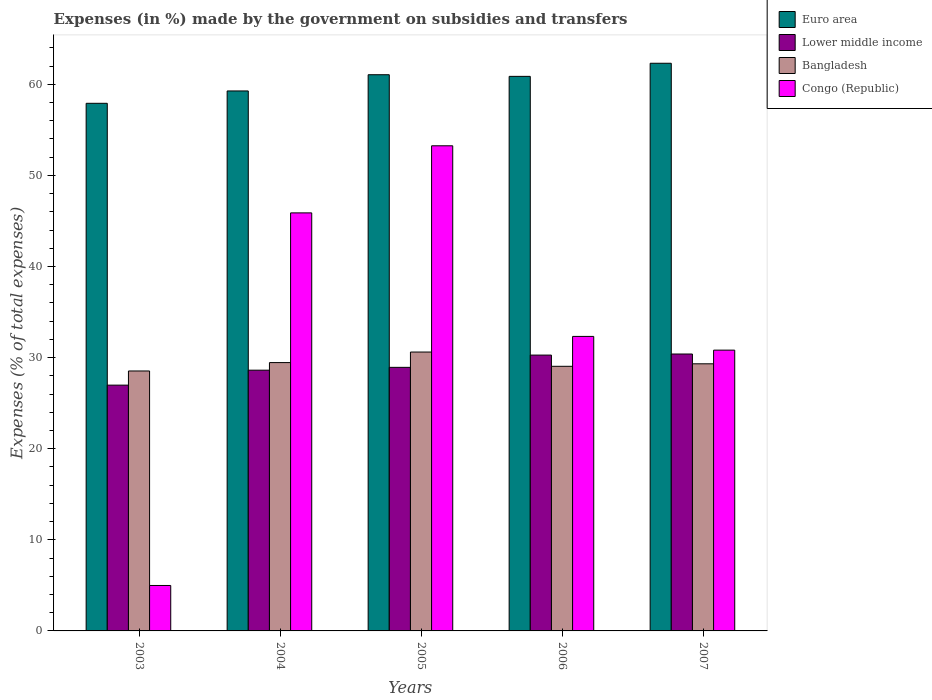How many different coloured bars are there?
Provide a succinct answer. 4. Are the number of bars per tick equal to the number of legend labels?
Keep it short and to the point. Yes. What is the label of the 1st group of bars from the left?
Offer a very short reply. 2003. In how many cases, is the number of bars for a given year not equal to the number of legend labels?
Provide a short and direct response. 0. What is the percentage of expenses made by the government on subsidies and transfers in Bangladesh in 2003?
Ensure brevity in your answer.  28.53. Across all years, what is the maximum percentage of expenses made by the government on subsidies and transfers in Euro area?
Ensure brevity in your answer.  62.31. Across all years, what is the minimum percentage of expenses made by the government on subsidies and transfers in Bangladesh?
Your answer should be very brief. 28.53. In which year was the percentage of expenses made by the government on subsidies and transfers in Euro area minimum?
Provide a succinct answer. 2003. What is the total percentage of expenses made by the government on subsidies and transfers in Lower middle income in the graph?
Offer a very short reply. 145.2. What is the difference between the percentage of expenses made by the government on subsidies and transfers in Bangladesh in 2003 and that in 2006?
Your response must be concise. -0.51. What is the difference between the percentage of expenses made by the government on subsidies and transfers in Bangladesh in 2007 and the percentage of expenses made by the government on subsidies and transfers in Euro area in 2006?
Ensure brevity in your answer.  -31.55. What is the average percentage of expenses made by the government on subsidies and transfers in Congo (Republic) per year?
Your answer should be very brief. 33.45. In the year 2007, what is the difference between the percentage of expenses made by the government on subsidies and transfers in Lower middle income and percentage of expenses made by the government on subsidies and transfers in Bangladesh?
Provide a succinct answer. 1.07. In how many years, is the percentage of expenses made by the government on subsidies and transfers in Lower middle income greater than 26 %?
Make the answer very short. 5. What is the ratio of the percentage of expenses made by the government on subsidies and transfers in Lower middle income in 2004 to that in 2007?
Make the answer very short. 0.94. What is the difference between the highest and the second highest percentage of expenses made by the government on subsidies and transfers in Congo (Republic)?
Give a very brief answer. 7.37. What is the difference between the highest and the lowest percentage of expenses made by the government on subsidies and transfers in Lower middle income?
Make the answer very short. 3.42. In how many years, is the percentage of expenses made by the government on subsidies and transfers in Congo (Republic) greater than the average percentage of expenses made by the government on subsidies and transfers in Congo (Republic) taken over all years?
Your answer should be very brief. 2. Is it the case that in every year, the sum of the percentage of expenses made by the government on subsidies and transfers in Bangladesh and percentage of expenses made by the government on subsidies and transfers in Lower middle income is greater than the sum of percentage of expenses made by the government on subsidies and transfers in Euro area and percentage of expenses made by the government on subsidies and transfers in Congo (Republic)?
Offer a very short reply. No. What does the 1st bar from the right in 2003 represents?
Offer a terse response. Congo (Republic). Is it the case that in every year, the sum of the percentage of expenses made by the government on subsidies and transfers in Bangladesh and percentage of expenses made by the government on subsidies and transfers in Lower middle income is greater than the percentage of expenses made by the government on subsidies and transfers in Congo (Republic)?
Ensure brevity in your answer.  Yes. How many bars are there?
Your answer should be very brief. 20. What is the difference between two consecutive major ticks on the Y-axis?
Your response must be concise. 10. Does the graph contain grids?
Keep it short and to the point. No. Where does the legend appear in the graph?
Make the answer very short. Top right. How many legend labels are there?
Provide a succinct answer. 4. What is the title of the graph?
Offer a terse response. Expenses (in %) made by the government on subsidies and transfers. What is the label or title of the Y-axis?
Provide a short and direct response. Expenses (% of total expenses). What is the Expenses (% of total expenses) in Euro area in 2003?
Provide a short and direct response. 57.91. What is the Expenses (% of total expenses) in Lower middle income in 2003?
Keep it short and to the point. 26.98. What is the Expenses (% of total expenses) of Bangladesh in 2003?
Offer a very short reply. 28.53. What is the Expenses (% of total expenses) in Congo (Republic) in 2003?
Keep it short and to the point. 4.99. What is the Expenses (% of total expenses) of Euro area in 2004?
Keep it short and to the point. 59.27. What is the Expenses (% of total expenses) of Lower middle income in 2004?
Your answer should be very brief. 28.62. What is the Expenses (% of total expenses) of Bangladesh in 2004?
Provide a succinct answer. 29.45. What is the Expenses (% of total expenses) in Congo (Republic) in 2004?
Make the answer very short. 45.89. What is the Expenses (% of total expenses) of Euro area in 2005?
Provide a short and direct response. 61.05. What is the Expenses (% of total expenses) in Lower middle income in 2005?
Provide a succinct answer. 28.93. What is the Expenses (% of total expenses) in Bangladesh in 2005?
Make the answer very short. 30.61. What is the Expenses (% of total expenses) of Congo (Republic) in 2005?
Ensure brevity in your answer.  53.25. What is the Expenses (% of total expenses) in Euro area in 2006?
Offer a very short reply. 60.87. What is the Expenses (% of total expenses) of Lower middle income in 2006?
Your answer should be compact. 30.28. What is the Expenses (% of total expenses) of Bangladesh in 2006?
Make the answer very short. 29.05. What is the Expenses (% of total expenses) in Congo (Republic) in 2006?
Your answer should be very brief. 32.33. What is the Expenses (% of total expenses) in Euro area in 2007?
Offer a terse response. 62.31. What is the Expenses (% of total expenses) of Lower middle income in 2007?
Offer a terse response. 30.39. What is the Expenses (% of total expenses) in Bangladesh in 2007?
Your answer should be compact. 29.32. What is the Expenses (% of total expenses) of Congo (Republic) in 2007?
Make the answer very short. 30.82. Across all years, what is the maximum Expenses (% of total expenses) of Euro area?
Make the answer very short. 62.31. Across all years, what is the maximum Expenses (% of total expenses) of Lower middle income?
Ensure brevity in your answer.  30.39. Across all years, what is the maximum Expenses (% of total expenses) in Bangladesh?
Keep it short and to the point. 30.61. Across all years, what is the maximum Expenses (% of total expenses) of Congo (Republic)?
Provide a succinct answer. 53.25. Across all years, what is the minimum Expenses (% of total expenses) in Euro area?
Your answer should be compact. 57.91. Across all years, what is the minimum Expenses (% of total expenses) in Lower middle income?
Ensure brevity in your answer.  26.98. Across all years, what is the minimum Expenses (% of total expenses) of Bangladesh?
Offer a terse response. 28.53. Across all years, what is the minimum Expenses (% of total expenses) in Congo (Republic)?
Provide a short and direct response. 4.99. What is the total Expenses (% of total expenses) in Euro area in the graph?
Ensure brevity in your answer.  301.41. What is the total Expenses (% of total expenses) in Lower middle income in the graph?
Your response must be concise. 145.2. What is the total Expenses (% of total expenses) in Bangladesh in the graph?
Ensure brevity in your answer.  146.96. What is the total Expenses (% of total expenses) in Congo (Republic) in the graph?
Your answer should be very brief. 167.27. What is the difference between the Expenses (% of total expenses) of Euro area in 2003 and that in 2004?
Offer a terse response. -1.36. What is the difference between the Expenses (% of total expenses) of Lower middle income in 2003 and that in 2004?
Your answer should be very brief. -1.64. What is the difference between the Expenses (% of total expenses) in Bangladesh in 2003 and that in 2004?
Your answer should be compact. -0.92. What is the difference between the Expenses (% of total expenses) in Congo (Republic) in 2003 and that in 2004?
Ensure brevity in your answer.  -40.9. What is the difference between the Expenses (% of total expenses) in Euro area in 2003 and that in 2005?
Your response must be concise. -3.14. What is the difference between the Expenses (% of total expenses) in Lower middle income in 2003 and that in 2005?
Make the answer very short. -1.95. What is the difference between the Expenses (% of total expenses) in Bangladesh in 2003 and that in 2005?
Offer a very short reply. -2.08. What is the difference between the Expenses (% of total expenses) of Congo (Republic) in 2003 and that in 2005?
Your response must be concise. -48.26. What is the difference between the Expenses (% of total expenses) of Euro area in 2003 and that in 2006?
Make the answer very short. -2.96. What is the difference between the Expenses (% of total expenses) in Lower middle income in 2003 and that in 2006?
Ensure brevity in your answer.  -3.3. What is the difference between the Expenses (% of total expenses) of Bangladesh in 2003 and that in 2006?
Offer a very short reply. -0.51. What is the difference between the Expenses (% of total expenses) in Congo (Republic) in 2003 and that in 2006?
Provide a succinct answer. -27.34. What is the difference between the Expenses (% of total expenses) in Euro area in 2003 and that in 2007?
Offer a very short reply. -4.4. What is the difference between the Expenses (% of total expenses) in Lower middle income in 2003 and that in 2007?
Ensure brevity in your answer.  -3.42. What is the difference between the Expenses (% of total expenses) in Bangladesh in 2003 and that in 2007?
Your answer should be compact. -0.79. What is the difference between the Expenses (% of total expenses) of Congo (Republic) in 2003 and that in 2007?
Your response must be concise. -25.83. What is the difference between the Expenses (% of total expenses) in Euro area in 2004 and that in 2005?
Ensure brevity in your answer.  -1.78. What is the difference between the Expenses (% of total expenses) in Lower middle income in 2004 and that in 2005?
Offer a terse response. -0.31. What is the difference between the Expenses (% of total expenses) of Bangladesh in 2004 and that in 2005?
Provide a succinct answer. -1.16. What is the difference between the Expenses (% of total expenses) in Congo (Republic) in 2004 and that in 2005?
Ensure brevity in your answer.  -7.37. What is the difference between the Expenses (% of total expenses) in Euro area in 2004 and that in 2006?
Provide a short and direct response. -1.6. What is the difference between the Expenses (% of total expenses) of Lower middle income in 2004 and that in 2006?
Give a very brief answer. -1.66. What is the difference between the Expenses (% of total expenses) in Bangladesh in 2004 and that in 2006?
Your answer should be compact. 0.41. What is the difference between the Expenses (% of total expenses) in Congo (Republic) in 2004 and that in 2006?
Your response must be concise. 13.56. What is the difference between the Expenses (% of total expenses) of Euro area in 2004 and that in 2007?
Offer a very short reply. -3.04. What is the difference between the Expenses (% of total expenses) in Lower middle income in 2004 and that in 2007?
Provide a short and direct response. -1.78. What is the difference between the Expenses (% of total expenses) of Bangladesh in 2004 and that in 2007?
Ensure brevity in your answer.  0.13. What is the difference between the Expenses (% of total expenses) of Congo (Republic) in 2004 and that in 2007?
Make the answer very short. 15.06. What is the difference between the Expenses (% of total expenses) in Euro area in 2005 and that in 2006?
Ensure brevity in your answer.  0.18. What is the difference between the Expenses (% of total expenses) in Lower middle income in 2005 and that in 2006?
Provide a short and direct response. -1.35. What is the difference between the Expenses (% of total expenses) in Bangladesh in 2005 and that in 2006?
Your answer should be very brief. 1.57. What is the difference between the Expenses (% of total expenses) of Congo (Republic) in 2005 and that in 2006?
Offer a very short reply. 20.92. What is the difference between the Expenses (% of total expenses) in Euro area in 2005 and that in 2007?
Make the answer very short. -1.26. What is the difference between the Expenses (% of total expenses) in Lower middle income in 2005 and that in 2007?
Keep it short and to the point. -1.46. What is the difference between the Expenses (% of total expenses) of Bangladesh in 2005 and that in 2007?
Provide a short and direct response. 1.29. What is the difference between the Expenses (% of total expenses) in Congo (Republic) in 2005 and that in 2007?
Ensure brevity in your answer.  22.43. What is the difference between the Expenses (% of total expenses) in Euro area in 2006 and that in 2007?
Offer a very short reply. -1.44. What is the difference between the Expenses (% of total expenses) of Lower middle income in 2006 and that in 2007?
Your answer should be compact. -0.12. What is the difference between the Expenses (% of total expenses) of Bangladesh in 2006 and that in 2007?
Your response must be concise. -0.27. What is the difference between the Expenses (% of total expenses) of Congo (Republic) in 2006 and that in 2007?
Give a very brief answer. 1.5. What is the difference between the Expenses (% of total expenses) of Euro area in 2003 and the Expenses (% of total expenses) of Lower middle income in 2004?
Your response must be concise. 29.29. What is the difference between the Expenses (% of total expenses) in Euro area in 2003 and the Expenses (% of total expenses) in Bangladesh in 2004?
Offer a very short reply. 28.46. What is the difference between the Expenses (% of total expenses) of Euro area in 2003 and the Expenses (% of total expenses) of Congo (Republic) in 2004?
Provide a short and direct response. 12.03. What is the difference between the Expenses (% of total expenses) in Lower middle income in 2003 and the Expenses (% of total expenses) in Bangladesh in 2004?
Give a very brief answer. -2.47. What is the difference between the Expenses (% of total expenses) in Lower middle income in 2003 and the Expenses (% of total expenses) in Congo (Republic) in 2004?
Provide a short and direct response. -18.91. What is the difference between the Expenses (% of total expenses) of Bangladesh in 2003 and the Expenses (% of total expenses) of Congo (Republic) in 2004?
Ensure brevity in your answer.  -17.35. What is the difference between the Expenses (% of total expenses) in Euro area in 2003 and the Expenses (% of total expenses) in Lower middle income in 2005?
Provide a succinct answer. 28.98. What is the difference between the Expenses (% of total expenses) of Euro area in 2003 and the Expenses (% of total expenses) of Bangladesh in 2005?
Your response must be concise. 27.3. What is the difference between the Expenses (% of total expenses) of Euro area in 2003 and the Expenses (% of total expenses) of Congo (Republic) in 2005?
Provide a short and direct response. 4.66. What is the difference between the Expenses (% of total expenses) in Lower middle income in 2003 and the Expenses (% of total expenses) in Bangladesh in 2005?
Offer a terse response. -3.63. What is the difference between the Expenses (% of total expenses) of Lower middle income in 2003 and the Expenses (% of total expenses) of Congo (Republic) in 2005?
Give a very brief answer. -26.27. What is the difference between the Expenses (% of total expenses) of Bangladesh in 2003 and the Expenses (% of total expenses) of Congo (Republic) in 2005?
Offer a very short reply. -24.72. What is the difference between the Expenses (% of total expenses) in Euro area in 2003 and the Expenses (% of total expenses) in Lower middle income in 2006?
Provide a short and direct response. 27.64. What is the difference between the Expenses (% of total expenses) in Euro area in 2003 and the Expenses (% of total expenses) in Bangladesh in 2006?
Offer a very short reply. 28.87. What is the difference between the Expenses (% of total expenses) of Euro area in 2003 and the Expenses (% of total expenses) of Congo (Republic) in 2006?
Offer a very short reply. 25.59. What is the difference between the Expenses (% of total expenses) of Lower middle income in 2003 and the Expenses (% of total expenses) of Bangladesh in 2006?
Keep it short and to the point. -2.07. What is the difference between the Expenses (% of total expenses) in Lower middle income in 2003 and the Expenses (% of total expenses) in Congo (Republic) in 2006?
Offer a terse response. -5.35. What is the difference between the Expenses (% of total expenses) of Bangladesh in 2003 and the Expenses (% of total expenses) of Congo (Republic) in 2006?
Provide a succinct answer. -3.79. What is the difference between the Expenses (% of total expenses) of Euro area in 2003 and the Expenses (% of total expenses) of Lower middle income in 2007?
Give a very brief answer. 27.52. What is the difference between the Expenses (% of total expenses) in Euro area in 2003 and the Expenses (% of total expenses) in Bangladesh in 2007?
Offer a very short reply. 28.59. What is the difference between the Expenses (% of total expenses) in Euro area in 2003 and the Expenses (% of total expenses) in Congo (Republic) in 2007?
Provide a succinct answer. 27.09. What is the difference between the Expenses (% of total expenses) in Lower middle income in 2003 and the Expenses (% of total expenses) in Bangladesh in 2007?
Your response must be concise. -2.34. What is the difference between the Expenses (% of total expenses) in Lower middle income in 2003 and the Expenses (% of total expenses) in Congo (Republic) in 2007?
Give a very brief answer. -3.84. What is the difference between the Expenses (% of total expenses) of Bangladesh in 2003 and the Expenses (% of total expenses) of Congo (Republic) in 2007?
Keep it short and to the point. -2.29. What is the difference between the Expenses (% of total expenses) in Euro area in 2004 and the Expenses (% of total expenses) in Lower middle income in 2005?
Provide a short and direct response. 30.34. What is the difference between the Expenses (% of total expenses) of Euro area in 2004 and the Expenses (% of total expenses) of Bangladesh in 2005?
Make the answer very short. 28.66. What is the difference between the Expenses (% of total expenses) in Euro area in 2004 and the Expenses (% of total expenses) in Congo (Republic) in 2005?
Offer a very short reply. 6.02. What is the difference between the Expenses (% of total expenses) in Lower middle income in 2004 and the Expenses (% of total expenses) in Bangladesh in 2005?
Give a very brief answer. -1.99. What is the difference between the Expenses (% of total expenses) in Lower middle income in 2004 and the Expenses (% of total expenses) in Congo (Republic) in 2005?
Offer a very short reply. -24.63. What is the difference between the Expenses (% of total expenses) in Bangladesh in 2004 and the Expenses (% of total expenses) in Congo (Republic) in 2005?
Provide a succinct answer. -23.8. What is the difference between the Expenses (% of total expenses) of Euro area in 2004 and the Expenses (% of total expenses) of Lower middle income in 2006?
Ensure brevity in your answer.  28.99. What is the difference between the Expenses (% of total expenses) of Euro area in 2004 and the Expenses (% of total expenses) of Bangladesh in 2006?
Ensure brevity in your answer.  30.22. What is the difference between the Expenses (% of total expenses) of Euro area in 2004 and the Expenses (% of total expenses) of Congo (Republic) in 2006?
Your answer should be compact. 26.94. What is the difference between the Expenses (% of total expenses) of Lower middle income in 2004 and the Expenses (% of total expenses) of Bangladesh in 2006?
Make the answer very short. -0.43. What is the difference between the Expenses (% of total expenses) in Lower middle income in 2004 and the Expenses (% of total expenses) in Congo (Republic) in 2006?
Offer a very short reply. -3.71. What is the difference between the Expenses (% of total expenses) of Bangladesh in 2004 and the Expenses (% of total expenses) of Congo (Republic) in 2006?
Provide a succinct answer. -2.87. What is the difference between the Expenses (% of total expenses) of Euro area in 2004 and the Expenses (% of total expenses) of Lower middle income in 2007?
Provide a short and direct response. 28.87. What is the difference between the Expenses (% of total expenses) in Euro area in 2004 and the Expenses (% of total expenses) in Bangladesh in 2007?
Ensure brevity in your answer.  29.95. What is the difference between the Expenses (% of total expenses) in Euro area in 2004 and the Expenses (% of total expenses) in Congo (Republic) in 2007?
Provide a succinct answer. 28.45. What is the difference between the Expenses (% of total expenses) of Lower middle income in 2004 and the Expenses (% of total expenses) of Bangladesh in 2007?
Give a very brief answer. -0.7. What is the difference between the Expenses (% of total expenses) in Lower middle income in 2004 and the Expenses (% of total expenses) in Congo (Republic) in 2007?
Provide a short and direct response. -2.2. What is the difference between the Expenses (% of total expenses) in Bangladesh in 2004 and the Expenses (% of total expenses) in Congo (Republic) in 2007?
Provide a succinct answer. -1.37. What is the difference between the Expenses (% of total expenses) of Euro area in 2005 and the Expenses (% of total expenses) of Lower middle income in 2006?
Offer a very short reply. 30.77. What is the difference between the Expenses (% of total expenses) in Euro area in 2005 and the Expenses (% of total expenses) in Bangladesh in 2006?
Offer a terse response. 32. What is the difference between the Expenses (% of total expenses) in Euro area in 2005 and the Expenses (% of total expenses) in Congo (Republic) in 2006?
Keep it short and to the point. 28.72. What is the difference between the Expenses (% of total expenses) of Lower middle income in 2005 and the Expenses (% of total expenses) of Bangladesh in 2006?
Keep it short and to the point. -0.12. What is the difference between the Expenses (% of total expenses) in Lower middle income in 2005 and the Expenses (% of total expenses) in Congo (Republic) in 2006?
Ensure brevity in your answer.  -3.4. What is the difference between the Expenses (% of total expenses) of Bangladesh in 2005 and the Expenses (% of total expenses) of Congo (Republic) in 2006?
Offer a very short reply. -1.71. What is the difference between the Expenses (% of total expenses) of Euro area in 2005 and the Expenses (% of total expenses) of Lower middle income in 2007?
Provide a short and direct response. 30.66. What is the difference between the Expenses (% of total expenses) in Euro area in 2005 and the Expenses (% of total expenses) in Bangladesh in 2007?
Your response must be concise. 31.73. What is the difference between the Expenses (% of total expenses) in Euro area in 2005 and the Expenses (% of total expenses) in Congo (Republic) in 2007?
Offer a terse response. 30.23. What is the difference between the Expenses (% of total expenses) of Lower middle income in 2005 and the Expenses (% of total expenses) of Bangladesh in 2007?
Make the answer very short. -0.39. What is the difference between the Expenses (% of total expenses) in Lower middle income in 2005 and the Expenses (% of total expenses) in Congo (Republic) in 2007?
Provide a short and direct response. -1.89. What is the difference between the Expenses (% of total expenses) in Bangladesh in 2005 and the Expenses (% of total expenses) in Congo (Republic) in 2007?
Your response must be concise. -0.21. What is the difference between the Expenses (% of total expenses) of Euro area in 2006 and the Expenses (% of total expenses) of Lower middle income in 2007?
Your response must be concise. 30.48. What is the difference between the Expenses (% of total expenses) of Euro area in 2006 and the Expenses (% of total expenses) of Bangladesh in 2007?
Offer a terse response. 31.55. What is the difference between the Expenses (% of total expenses) of Euro area in 2006 and the Expenses (% of total expenses) of Congo (Republic) in 2007?
Ensure brevity in your answer.  30.05. What is the difference between the Expenses (% of total expenses) of Lower middle income in 2006 and the Expenses (% of total expenses) of Bangladesh in 2007?
Offer a very short reply. 0.96. What is the difference between the Expenses (% of total expenses) in Lower middle income in 2006 and the Expenses (% of total expenses) in Congo (Republic) in 2007?
Give a very brief answer. -0.54. What is the difference between the Expenses (% of total expenses) of Bangladesh in 2006 and the Expenses (% of total expenses) of Congo (Republic) in 2007?
Provide a succinct answer. -1.78. What is the average Expenses (% of total expenses) of Euro area per year?
Give a very brief answer. 60.28. What is the average Expenses (% of total expenses) in Lower middle income per year?
Offer a terse response. 29.04. What is the average Expenses (% of total expenses) in Bangladesh per year?
Keep it short and to the point. 29.39. What is the average Expenses (% of total expenses) of Congo (Republic) per year?
Provide a succinct answer. 33.45. In the year 2003, what is the difference between the Expenses (% of total expenses) of Euro area and Expenses (% of total expenses) of Lower middle income?
Ensure brevity in your answer.  30.93. In the year 2003, what is the difference between the Expenses (% of total expenses) of Euro area and Expenses (% of total expenses) of Bangladesh?
Give a very brief answer. 29.38. In the year 2003, what is the difference between the Expenses (% of total expenses) in Euro area and Expenses (% of total expenses) in Congo (Republic)?
Your answer should be very brief. 52.92. In the year 2003, what is the difference between the Expenses (% of total expenses) in Lower middle income and Expenses (% of total expenses) in Bangladesh?
Your response must be concise. -1.55. In the year 2003, what is the difference between the Expenses (% of total expenses) of Lower middle income and Expenses (% of total expenses) of Congo (Republic)?
Provide a short and direct response. 21.99. In the year 2003, what is the difference between the Expenses (% of total expenses) of Bangladesh and Expenses (% of total expenses) of Congo (Republic)?
Your answer should be compact. 23.54. In the year 2004, what is the difference between the Expenses (% of total expenses) of Euro area and Expenses (% of total expenses) of Lower middle income?
Provide a succinct answer. 30.65. In the year 2004, what is the difference between the Expenses (% of total expenses) of Euro area and Expenses (% of total expenses) of Bangladesh?
Provide a short and direct response. 29.82. In the year 2004, what is the difference between the Expenses (% of total expenses) of Euro area and Expenses (% of total expenses) of Congo (Republic)?
Your response must be concise. 13.38. In the year 2004, what is the difference between the Expenses (% of total expenses) of Lower middle income and Expenses (% of total expenses) of Bangladesh?
Offer a terse response. -0.83. In the year 2004, what is the difference between the Expenses (% of total expenses) of Lower middle income and Expenses (% of total expenses) of Congo (Republic)?
Offer a terse response. -17.27. In the year 2004, what is the difference between the Expenses (% of total expenses) in Bangladesh and Expenses (% of total expenses) in Congo (Republic)?
Provide a succinct answer. -16.43. In the year 2005, what is the difference between the Expenses (% of total expenses) of Euro area and Expenses (% of total expenses) of Lower middle income?
Keep it short and to the point. 32.12. In the year 2005, what is the difference between the Expenses (% of total expenses) in Euro area and Expenses (% of total expenses) in Bangladesh?
Offer a very short reply. 30.44. In the year 2005, what is the difference between the Expenses (% of total expenses) in Euro area and Expenses (% of total expenses) in Congo (Republic)?
Make the answer very short. 7.8. In the year 2005, what is the difference between the Expenses (% of total expenses) of Lower middle income and Expenses (% of total expenses) of Bangladesh?
Ensure brevity in your answer.  -1.68. In the year 2005, what is the difference between the Expenses (% of total expenses) of Lower middle income and Expenses (% of total expenses) of Congo (Republic)?
Offer a very short reply. -24.32. In the year 2005, what is the difference between the Expenses (% of total expenses) of Bangladesh and Expenses (% of total expenses) of Congo (Republic)?
Offer a terse response. -22.64. In the year 2006, what is the difference between the Expenses (% of total expenses) of Euro area and Expenses (% of total expenses) of Lower middle income?
Your answer should be compact. 30.59. In the year 2006, what is the difference between the Expenses (% of total expenses) in Euro area and Expenses (% of total expenses) in Bangladesh?
Ensure brevity in your answer.  31.82. In the year 2006, what is the difference between the Expenses (% of total expenses) of Euro area and Expenses (% of total expenses) of Congo (Republic)?
Your answer should be very brief. 28.54. In the year 2006, what is the difference between the Expenses (% of total expenses) of Lower middle income and Expenses (% of total expenses) of Bangladesh?
Provide a short and direct response. 1.23. In the year 2006, what is the difference between the Expenses (% of total expenses) of Lower middle income and Expenses (% of total expenses) of Congo (Republic)?
Provide a succinct answer. -2.05. In the year 2006, what is the difference between the Expenses (% of total expenses) in Bangladesh and Expenses (% of total expenses) in Congo (Republic)?
Your answer should be compact. -3.28. In the year 2007, what is the difference between the Expenses (% of total expenses) in Euro area and Expenses (% of total expenses) in Lower middle income?
Offer a terse response. 31.91. In the year 2007, what is the difference between the Expenses (% of total expenses) of Euro area and Expenses (% of total expenses) of Bangladesh?
Your answer should be compact. 32.99. In the year 2007, what is the difference between the Expenses (% of total expenses) of Euro area and Expenses (% of total expenses) of Congo (Republic)?
Offer a terse response. 31.49. In the year 2007, what is the difference between the Expenses (% of total expenses) in Lower middle income and Expenses (% of total expenses) in Bangladesh?
Your answer should be very brief. 1.07. In the year 2007, what is the difference between the Expenses (% of total expenses) of Lower middle income and Expenses (% of total expenses) of Congo (Republic)?
Give a very brief answer. -0.43. In the year 2007, what is the difference between the Expenses (% of total expenses) in Bangladesh and Expenses (% of total expenses) in Congo (Republic)?
Provide a short and direct response. -1.5. What is the ratio of the Expenses (% of total expenses) of Euro area in 2003 to that in 2004?
Your response must be concise. 0.98. What is the ratio of the Expenses (% of total expenses) in Lower middle income in 2003 to that in 2004?
Ensure brevity in your answer.  0.94. What is the ratio of the Expenses (% of total expenses) of Bangladesh in 2003 to that in 2004?
Your answer should be very brief. 0.97. What is the ratio of the Expenses (% of total expenses) in Congo (Republic) in 2003 to that in 2004?
Your answer should be very brief. 0.11. What is the ratio of the Expenses (% of total expenses) in Euro area in 2003 to that in 2005?
Your answer should be compact. 0.95. What is the ratio of the Expenses (% of total expenses) of Lower middle income in 2003 to that in 2005?
Give a very brief answer. 0.93. What is the ratio of the Expenses (% of total expenses) of Bangladesh in 2003 to that in 2005?
Your response must be concise. 0.93. What is the ratio of the Expenses (% of total expenses) in Congo (Republic) in 2003 to that in 2005?
Provide a short and direct response. 0.09. What is the ratio of the Expenses (% of total expenses) in Euro area in 2003 to that in 2006?
Your answer should be very brief. 0.95. What is the ratio of the Expenses (% of total expenses) in Lower middle income in 2003 to that in 2006?
Offer a very short reply. 0.89. What is the ratio of the Expenses (% of total expenses) of Bangladesh in 2003 to that in 2006?
Your response must be concise. 0.98. What is the ratio of the Expenses (% of total expenses) in Congo (Republic) in 2003 to that in 2006?
Your answer should be very brief. 0.15. What is the ratio of the Expenses (% of total expenses) of Euro area in 2003 to that in 2007?
Your answer should be compact. 0.93. What is the ratio of the Expenses (% of total expenses) in Lower middle income in 2003 to that in 2007?
Provide a short and direct response. 0.89. What is the ratio of the Expenses (% of total expenses) of Bangladesh in 2003 to that in 2007?
Your answer should be compact. 0.97. What is the ratio of the Expenses (% of total expenses) of Congo (Republic) in 2003 to that in 2007?
Make the answer very short. 0.16. What is the ratio of the Expenses (% of total expenses) in Euro area in 2004 to that in 2005?
Provide a succinct answer. 0.97. What is the ratio of the Expenses (% of total expenses) of Lower middle income in 2004 to that in 2005?
Offer a very short reply. 0.99. What is the ratio of the Expenses (% of total expenses) in Bangladesh in 2004 to that in 2005?
Give a very brief answer. 0.96. What is the ratio of the Expenses (% of total expenses) in Congo (Republic) in 2004 to that in 2005?
Make the answer very short. 0.86. What is the ratio of the Expenses (% of total expenses) of Euro area in 2004 to that in 2006?
Your answer should be compact. 0.97. What is the ratio of the Expenses (% of total expenses) of Lower middle income in 2004 to that in 2006?
Your response must be concise. 0.95. What is the ratio of the Expenses (% of total expenses) in Bangladesh in 2004 to that in 2006?
Keep it short and to the point. 1.01. What is the ratio of the Expenses (% of total expenses) of Congo (Republic) in 2004 to that in 2006?
Give a very brief answer. 1.42. What is the ratio of the Expenses (% of total expenses) in Euro area in 2004 to that in 2007?
Provide a short and direct response. 0.95. What is the ratio of the Expenses (% of total expenses) of Lower middle income in 2004 to that in 2007?
Your answer should be compact. 0.94. What is the ratio of the Expenses (% of total expenses) in Bangladesh in 2004 to that in 2007?
Ensure brevity in your answer.  1. What is the ratio of the Expenses (% of total expenses) in Congo (Republic) in 2004 to that in 2007?
Your response must be concise. 1.49. What is the ratio of the Expenses (% of total expenses) in Lower middle income in 2005 to that in 2006?
Keep it short and to the point. 0.96. What is the ratio of the Expenses (% of total expenses) in Bangladesh in 2005 to that in 2006?
Provide a succinct answer. 1.05. What is the ratio of the Expenses (% of total expenses) of Congo (Republic) in 2005 to that in 2006?
Your answer should be compact. 1.65. What is the ratio of the Expenses (% of total expenses) in Euro area in 2005 to that in 2007?
Provide a short and direct response. 0.98. What is the ratio of the Expenses (% of total expenses) of Lower middle income in 2005 to that in 2007?
Keep it short and to the point. 0.95. What is the ratio of the Expenses (% of total expenses) in Bangladesh in 2005 to that in 2007?
Ensure brevity in your answer.  1.04. What is the ratio of the Expenses (% of total expenses) in Congo (Republic) in 2005 to that in 2007?
Ensure brevity in your answer.  1.73. What is the ratio of the Expenses (% of total expenses) in Euro area in 2006 to that in 2007?
Offer a terse response. 0.98. What is the ratio of the Expenses (% of total expenses) of Lower middle income in 2006 to that in 2007?
Make the answer very short. 1. What is the ratio of the Expenses (% of total expenses) in Congo (Republic) in 2006 to that in 2007?
Keep it short and to the point. 1.05. What is the difference between the highest and the second highest Expenses (% of total expenses) in Euro area?
Ensure brevity in your answer.  1.26. What is the difference between the highest and the second highest Expenses (% of total expenses) of Lower middle income?
Your answer should be compact. 0.12. What is the difference between the highest and the second highest Expenses (% of total expenses) of Bangladesh?
Ensure brevity in your answer.  1.16. What is the difference between the highest and the second highest Expenses (% of total expenses) in Congo (Republic)?
Provide a short and direct response. 7.37. What is the difference between the highest and the lowest Expenses (% of total expenses) in Euro area?
Offer a very short reply. 4.4. What is the difference between the highest and the lowest Expenses (% of total expenses) of Lower middle income?
Keep it short and to the point. 3.42. What is the difference between the highest and the lowest Expenses (% of total expenses) of Bangladesh?
Your response must be concise. 2.08. What is the difference between the highest and the lowest Expenses (% of total expenses) of Congo (Republic)?
Give a very brief answer. 48.26. 